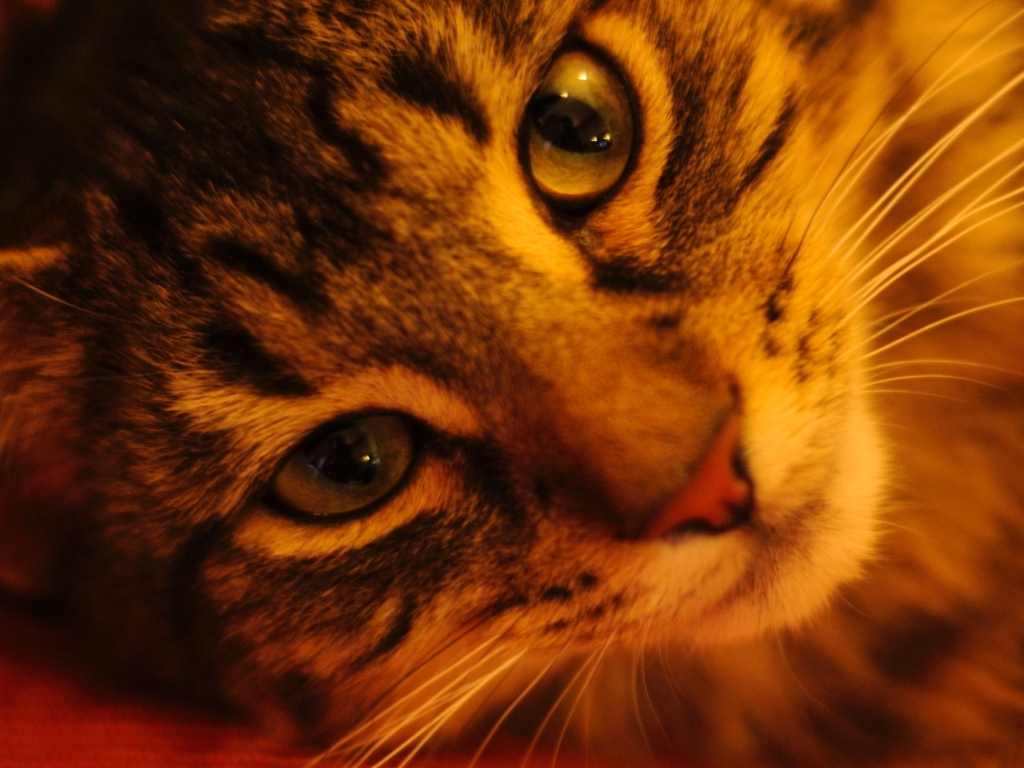How might this image make someone feel? This image might evoke a sense of warmth and serenity. The soft focus and the cat's gentle gaze can have a soothing effect, making viewers feel relaxed or bringing a smile to those who love animals. 